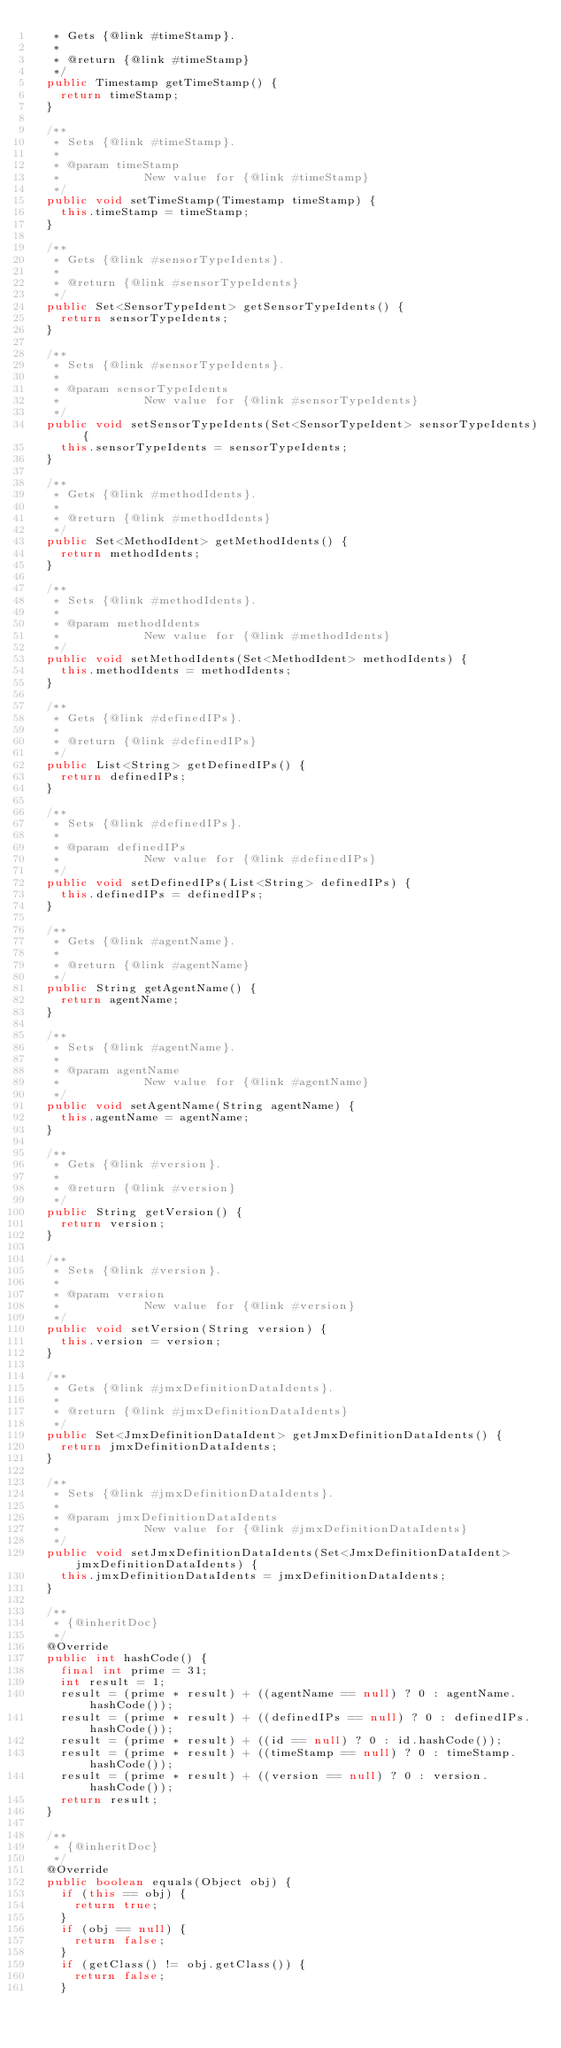Convert code to text. <code><loc_0><loc_0><loc_500><loc_500><_Java_>	 * Gets {@link #timeStamp}.
	 *
	 * @return {@link #timeStamp}
	 */
	public Timestamp getTimeStamp() {
		return timeStamp;
	}

	/**
	 * Sets {@link #timeStamp}.
	 *
	 * @param timeStamp
	 *            New value for {@link #timeStamp}
	 */
	public void setTimeStamp(Timestamp timeStamp) {
		this.timeStamp = timeStamp;
	}

	/**
	 * Gets {@link #sensorTypeIdents}.
	 *
	 * @return {@link #sensorTypeIdents}
	 */
	public Set<SensorTypeIdent> getSensorTypeIdents() {
		return sensorTypeIdents;
	}

	/**
	 * Sets {@link #sensorTypeIdents}.
	 *
	 * @param sensorTypeIdents
	 *            New value for {@link #sensorTypeIdents}
	 */
	public void setSensorTypeIdents(Set<SensorTypeIdent> sensorTypeIdents) {
		this.sensorTypeIdents = sensorTypeIdents;
	}

	/**
	 * Gets {@link #methodIdents}.
	 *
	 * @return {@link #methodIdents}
	 */
	public Set<MethodIdent> getMethodIdents() {
		return methodIdents;
	}

	/**
	 * Sets {@link #methodIdents}.
	 *
	 * @param methodIdents
	 *            New value for {@link #methodIdents}
	 */
	public void setMethodIdents(Set<MethodIdent> methodIdents) {
		this.methodIdents = methodIdents;
	}

	/**
	 * Gets {@link #definedIPs}.
	 *
	 * @return {@link #definedIPs}
	 */
	public List<String> getDefinedIPs() {
		return definedIPs;
	}

	/**
	 * Sets {@link #definedIPs}.
	 *
	 * @param definedIPs
	 *            New value for {@link #definedIPs}
	 */
	public void setDefinedIPs(List<String> definedIPs) {
		this.definedIPs = definedIPs;
	}

	/**
	 * Gets {@link #agentName}.
	 *
	 * @return {@link #agentName}
	 */
	public String getAgentName() {
		return agentName;
	}

	/**
	 * Sets {@link #agentName}.
	 *
	 * @param agentName
	 *            New value for {@link #agentName}
	 */
	public void setAgentName(String agentName) {
		this.agentName = agentName;
	}

	/**
	 * Gets {@link #version}.
	 *
	 * @return {@link #version}
	 */
	public String getVersion() {
		return version;
	}

	/**
	 * Sets {@link #version}.
	 *
	 * @param version
	 *            New value for {@link #version}
	 */
	public void setVersion(String version) {
		this.version = version;
	}

	/**
	 * Gets {@link #jmxDefinitionDataIdents}.
	 *
	 * @return {@link #jmxDefinitionDataIdents}
	 */
	public Set<JmxDefinitionDataIdent> getJmxDefinitionDataIdents() {
		return jmxDefinitionDataIdents;
	}

	/**
	 * Sets {@link #jmxDefinitionDataIdents}.
	 *
	 * @param jmxDefinitionDataIdents
	 *            New value for {@link #jmxDefinitionDataIdents}
	 */
	public void setJmxDefinitionDataIdents(Set<JmxDefinitionDataIdent> jmxDefinitionDataIdents) {
		this.jmxDefinitionDataIdents = jmxDefinitionDataIdents;
	}

	/**
	 * {@inheritDoc}
	 */
	@Override
	public int hashCode() {
		final int prime = 31;
		int result = 1;
		result = (prime * result) + ((agentName == null) ? 0 : agentName.hashCode());
		result = (prime * result) + ((definedIPs == null) ? 0 : definedIPs.hashCode());
		result = (prime * result) + ((id == null) ? 0 : id.hashCode());
		result = (prime * result) + ((timeStamp == null) ? 0 : timeStamp.hashCode());
		result = (prime * result) + ((version == null) ? 0 : version.hashCode());
		return result;
	}

	/**
	 * {@inheritDoc}
	 */
	@Override
	public boolean equals(Object obj) {
		if (this == obj) {
			return true;
		}
		if (obj == null) {
			return false;
		}
		if (getClass() != obj.getClass()) {
			return false;
		}</code> 